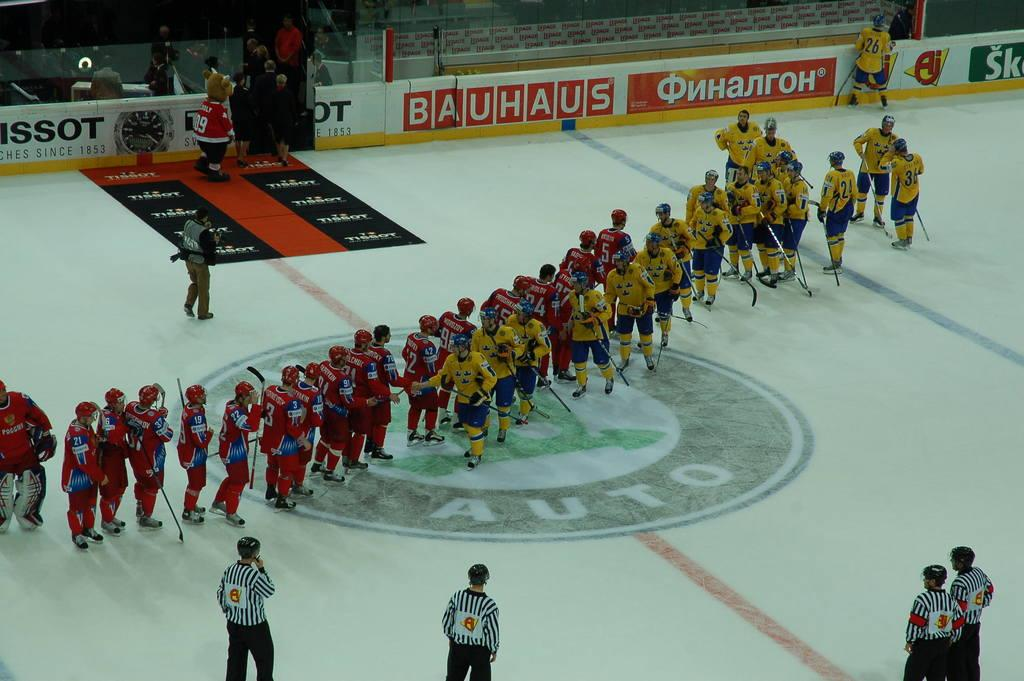What is the main focus of the image? The main focus of the image is the many people in the middle of the image. What are some people holding in the image? Some people are holding bats in the image. How many men are at the bottom of the image? There are four men at the bottom of the image. Can you describe the top of the image? At the top of the image, there are people and posters, as well as visible text. What type of board can be seen in the image? There is no board present in the image. What flight is taking off in the image? There is no flight present in the image. 